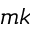Convert formula to latex. <formula><loc_0><loc_0><loc_500><loc_500>m k</formula> 